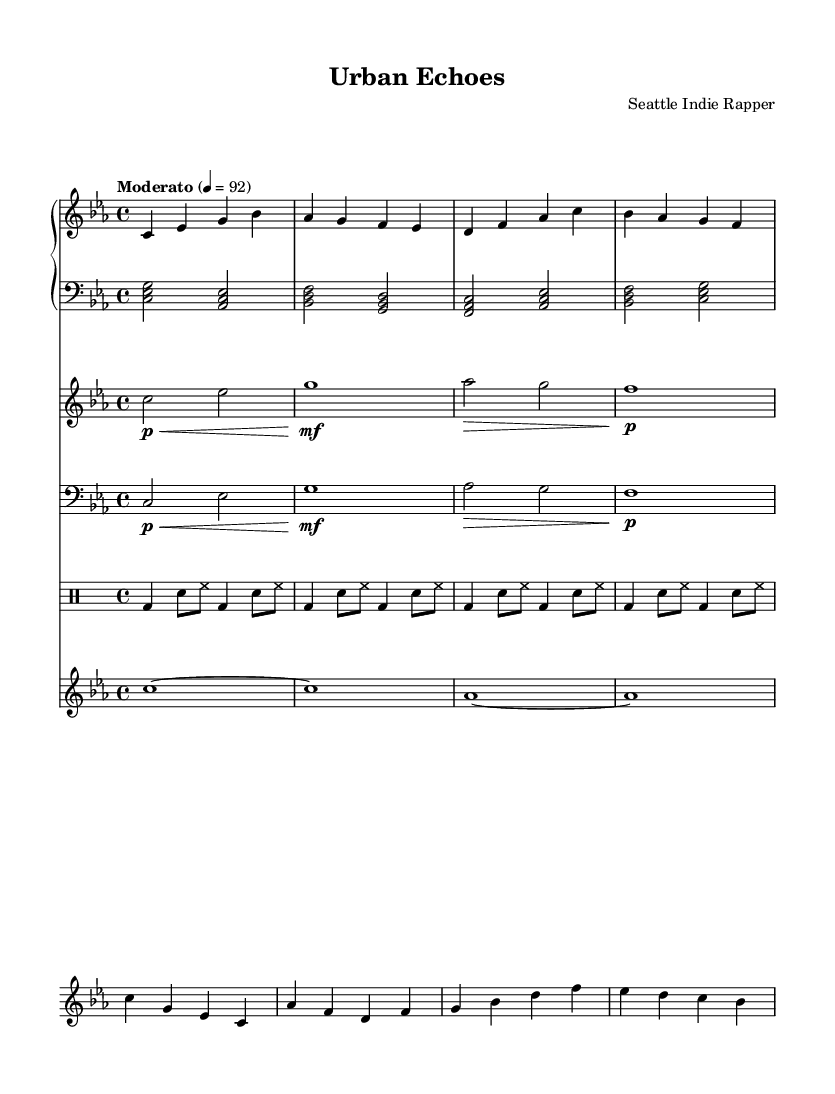What is the key signature of this music? The key signature is C minor, indicated by three flats (B flat, E flat, and A flat) on the staff.
Answer: C minor What is the time signature of this piece? The time signature is found at the beginning of the sheet music, showing four beats per measure, represented by the fraction 4/4.
Answer: 4/4 What is the tempo marking for this composition? The tempo marking, placed above the staff, is "Moderato," indicating a moderate speed, typically around 92 beats per minute.
Answer: Moderato How many measures are in the main theme? The main theme comprises four measures, as determined by counting the vertical lines (bar lines) that separate the sections of the music.
Answer: 4 Which instruments are featured in this score? The score includes piano (right and left hands), violin, cello, drums, and a synthesizer, all specified with their respective staves in the score layout.
Answer: Piano, violin, cello, drums, synthesizer What dynamic marking is indicated for the violin in the first measure? The dynamic marking in the first measure of the violin indicates a piano level, denoted by the symbol "p", which instructs the player to play softly.
Answer: Piano What kind of accompaniment is used in the left hand of the piano? The left hand of the piano features block chords played in half notes, which provide harmonic support for the melody of the right hand.
Answer: Block chords 